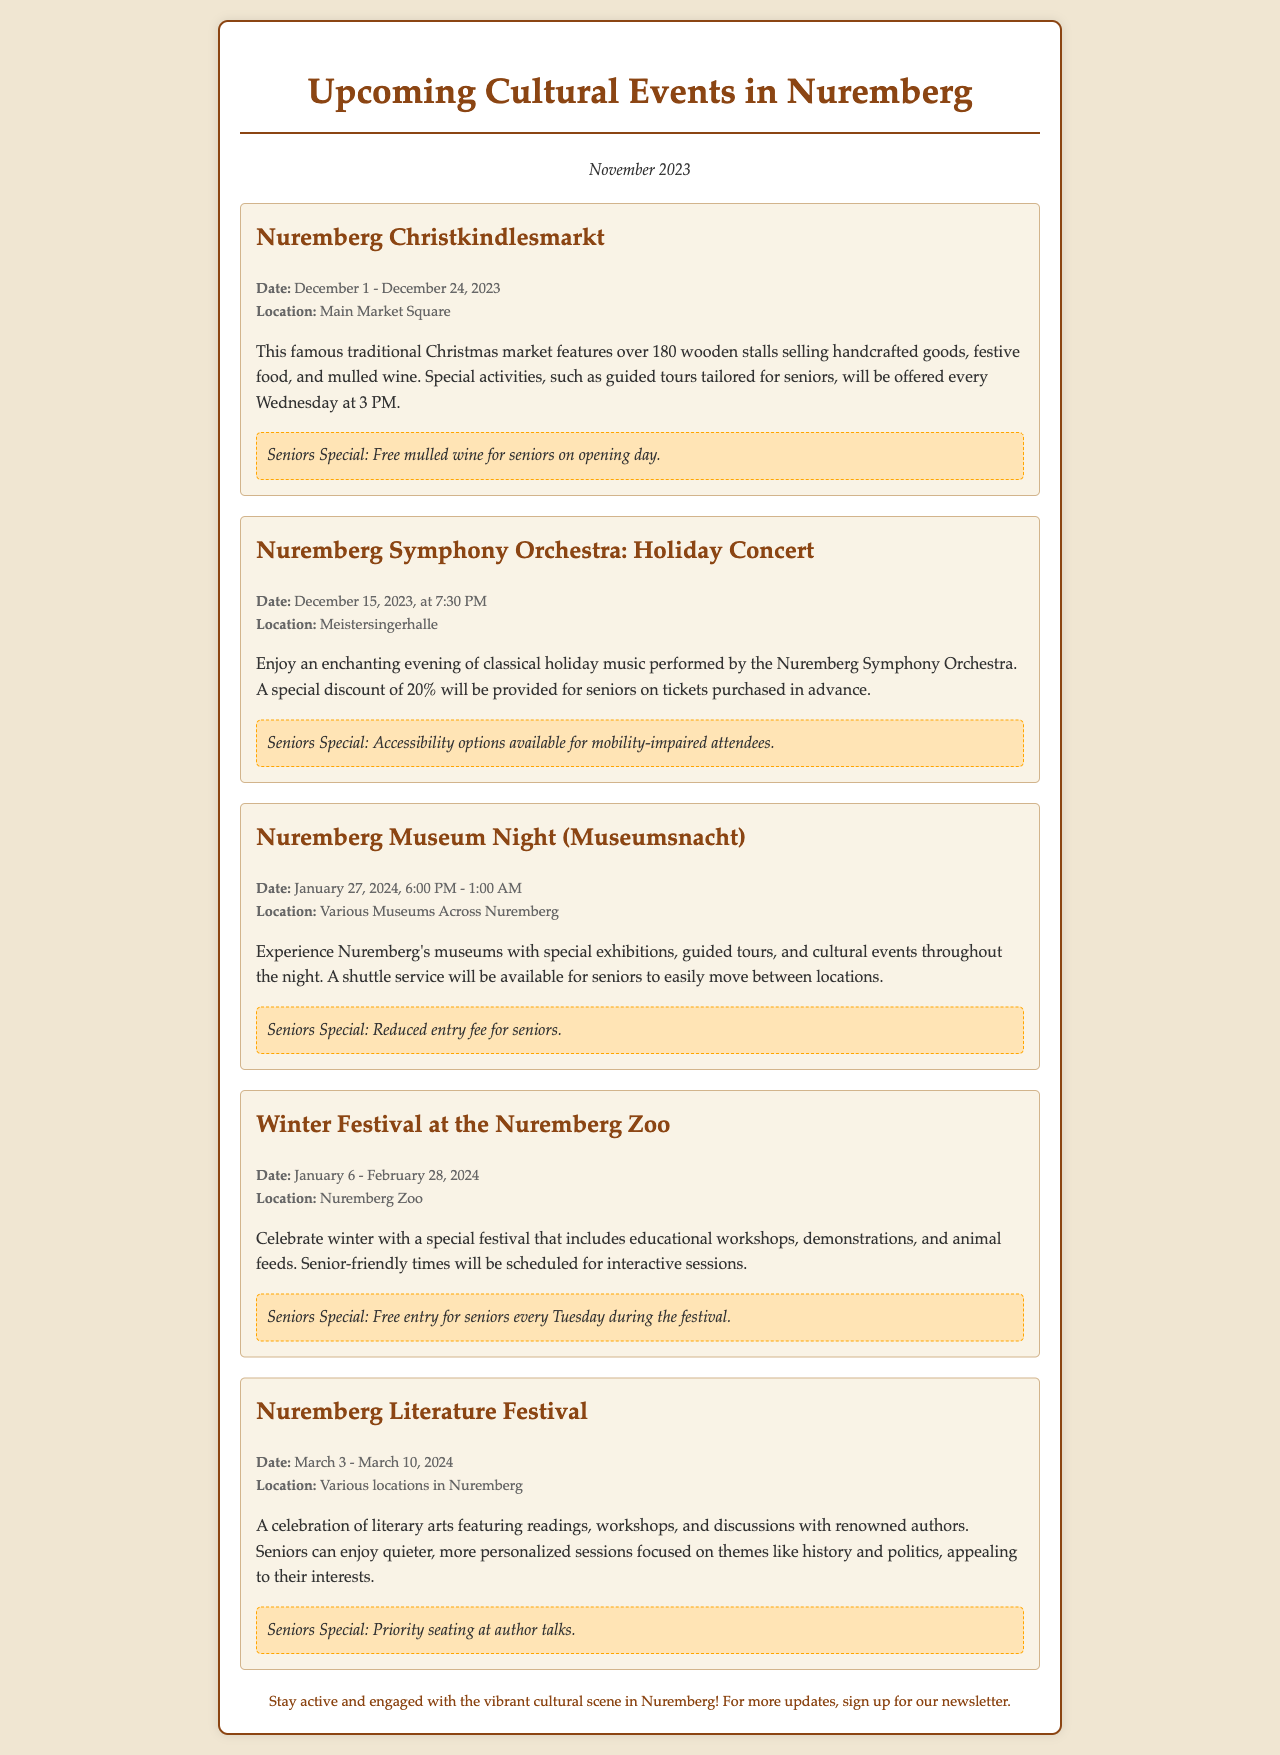What is the date range for the Nuremberg Christkindlesmarkt? The date range is from December 1 to December 24, 2023.
Answer: December 1 - December 24, 2023 What special offer is available for seniors on the opening day of the Nuremberg Christkindlesmarkt? Seniors will receive free mulled wine on the opening day.
Answer: Free mulled wine What time does the Nuremberg Symphony Orchestra's Holiday Concert start? The concert starts at 7:30 PM on December 15, 2023.
Answer: 7:30 PM What can seniors expect regarding mobility at the Nuremberg Symphony Orchestra concert? Accessibility options are available for mobility-impaired attendees.
Answer: Accessibility options When is the Nuremberg Museum Night scheduled to take place? The event is on January 27, 2024, from 6:00 PM to 1:00 AM.
Answer: January 27, 2024 What special service will be provided for seniors during the Nuremberg Museum Night? A shuttle service will be available for seniors.
Answer: Shuttle service What is the senior special offer during the Winter Festival at the Nuremberg Zoo? Seniors receive free entry every Tuesday during the festival.
Answer: Free entry every Tuesday What types of sessions are seniors encouraged to attend at the Nuremberg Literature Festival? Seniors can enjoy quieter, more personalized sessions focused on history and politics.
Answer: Quieter, more personalized sessions What is the duration of the Nuremberg Literature Festival? The festival lasts from March 3 to March 10, 2024.
Answer: March 3 - March 10, 2024 